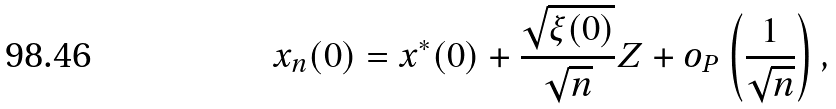Convert formula to latex. <formula><loc_0><loc_0><loc_500><loc_500>x _ { n } ( 0 ) = x ^ { * } ( 0 ) + \frac { \sqrt { \xi ( 0 ) } } { \sqrt { n } } Z + o _ { P } \left ( \frac { 1 } { \sqrt { n } } \right ) ,</formula> 